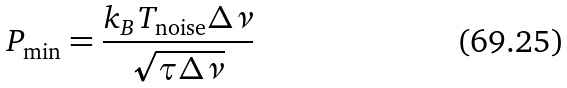Convert formula to latex. <formula><loc_0><loc_0><loc_500><loc_500>P _ { \min } = \frac { k _ { B } T _ { \text {noise} } \Delta \nu } { \sqrt { \tau \Delta \nu } }</formula> 